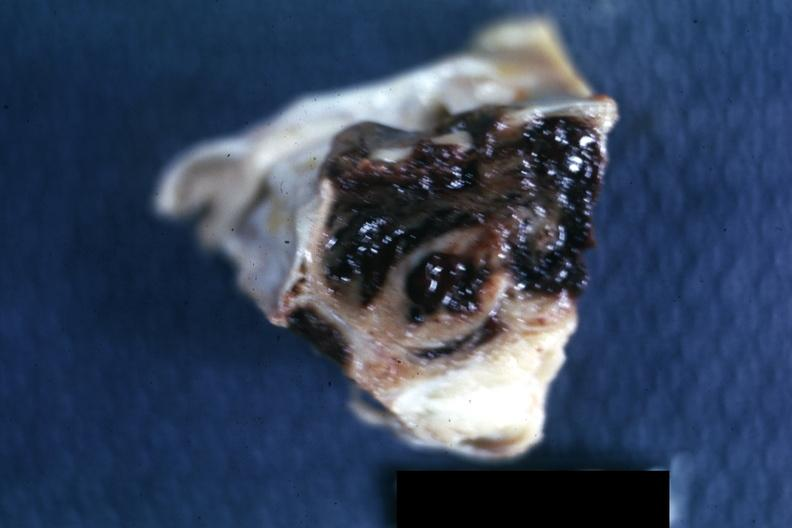s polycystic disease present?
Answer the question using a single word or phrase. No 